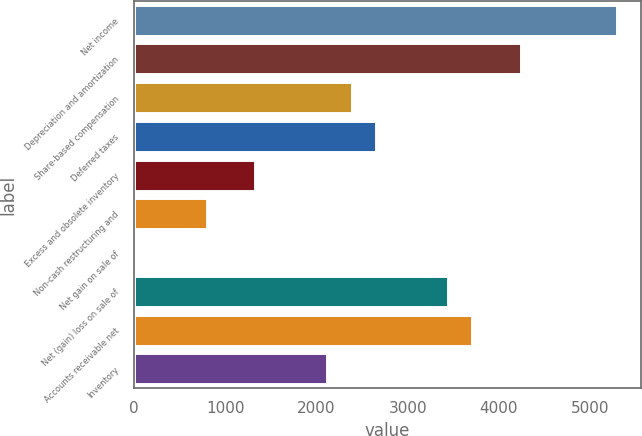Convert chart to OTSL. <chart><loc_0><loc_0><loc_500><loc_500><bar_chart><fcel>Net income<fcel>Depreciation and amortization<fcel>Share-based compensation<fcel>Deferred taxes<fcel>Excess and obsolete inventory<fcel>Non-cash restructuring and<fcel>Net gain on sale of<fcel>Net (gain) loss on sale of<fcel>Accounts receivable net<fcel>Inventory<nl><fcel>5296<fcel>4237.2<fcel>2384.3<fcel>2649<fcel>1325.5<fcel>796.1<fcel>2<fcel>3443.1<fcel>3707.8<fcel>2119.6<nl></chart> 